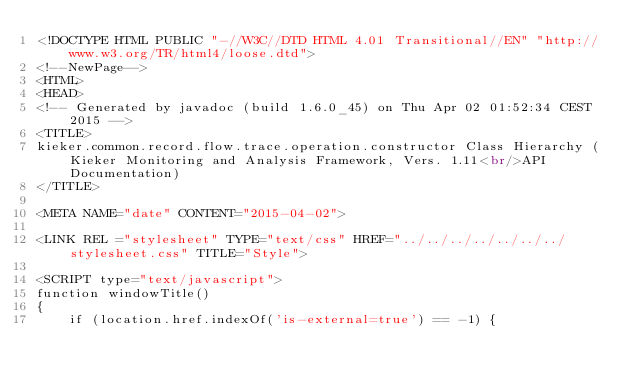<code> <loc_0><loc_0><loc_500><loc_500><_HTML_><!DOCTYPE HTML PUBLIC "-//W3C//DTD HTML 4.01 Transitional//EN" "http://www.w3.org/TR/html4/loose.dtd">
<!--NewPage-->
<HTML>
<HEAD>
<!-- Generated by javadoc (build 1.6.0_45) on Thu Apr 02 01:52:34 CEST 2015 -->
<TITLE>
kieker.common.record.flow.trace.operation.constructor Class Hierarchy (Kieker Monitoring and Analysis Framework, Vers. 1.11<br/>API Documentation)
</TITLE>

<META NAME="date" CONTENT="2015-04-02">

<LINK REL ="stylesheet" TYPE="text/css" HREF="../../../../../../../stylesheet.css" TITLE="Style">

<SCRIPT type="text/javascript">
function windowTitle()
{
    if (location.href.indexOf('is-external=true') == -1) {</code> 